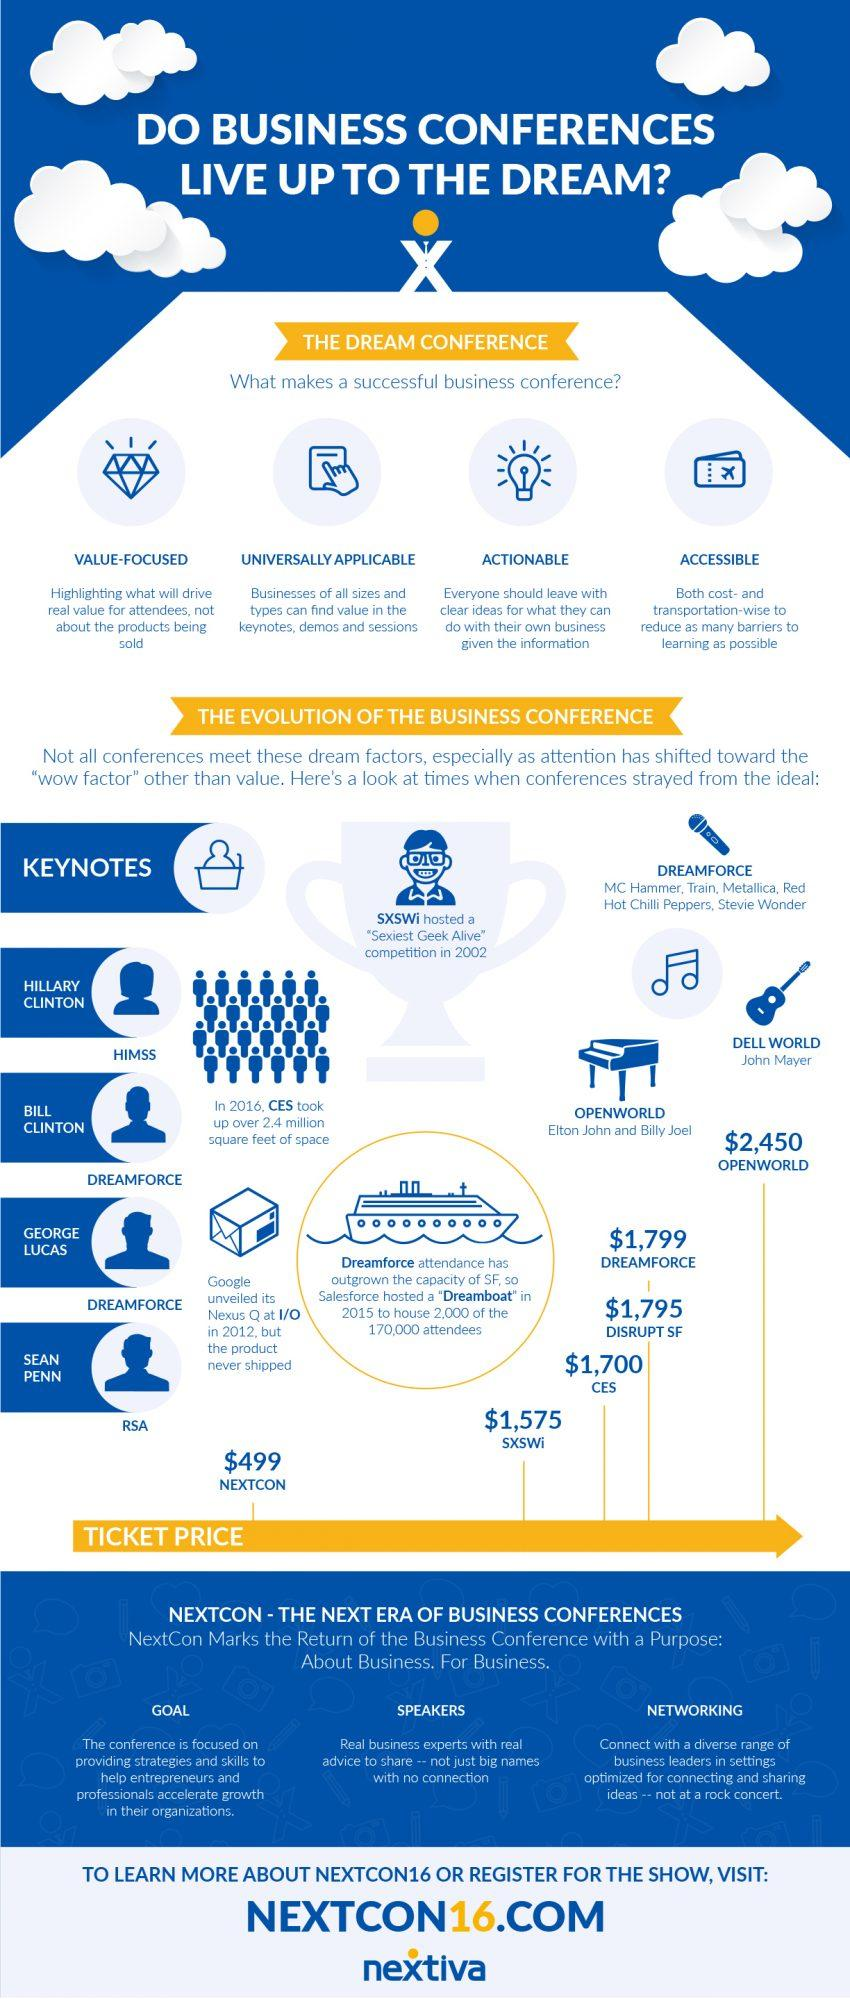Highlight a few significant elements in this photo. The ticket price for SXSWi is lower than $499. Dreamforce had a ticket price of $1,799. The product "Nexus Q" from Google was never shipped after its unveiling. The ticket price for Dreamforce was higher than Disrupt San Francisco by 4 dollars. Dreamforce featured performances by notable musicians such as MC Hammer, Train, Metallica, Red Hot Chilli Peppers, and Stevie Wonder. 